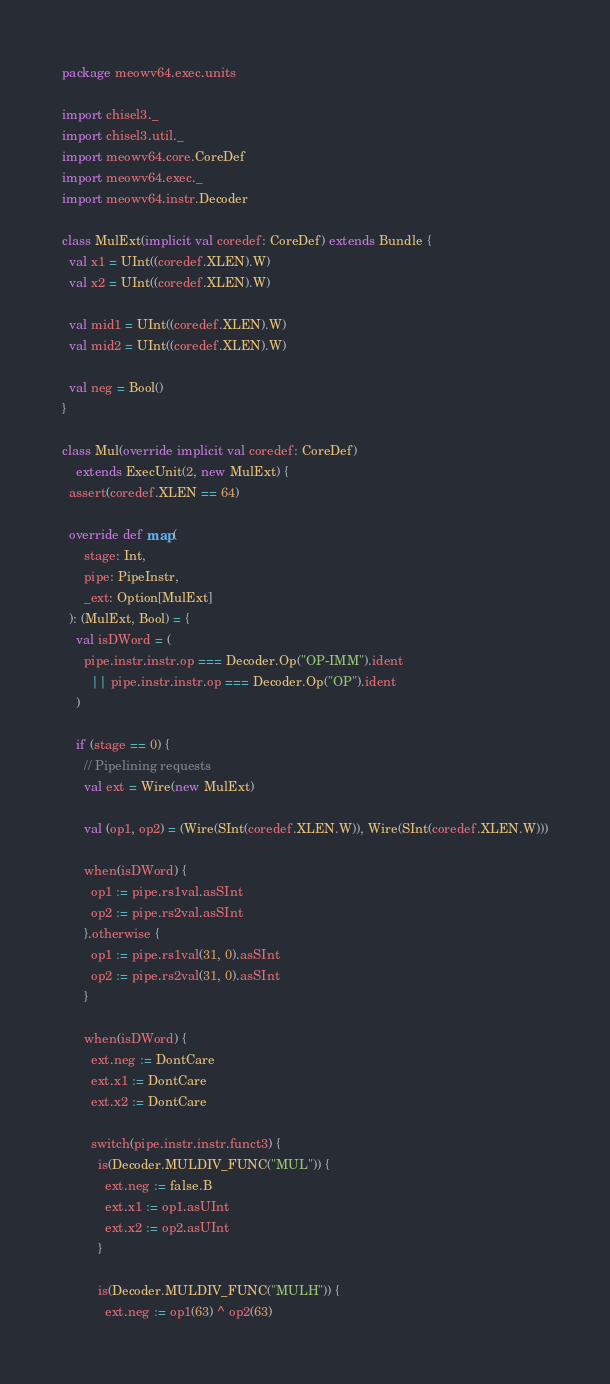Convert code to text. <code><loc_0><loc_0><loc_500><loc_500><_Scala_>package meowv64.exec.units

import chisel3._
import chisel3.util._
import meowv64.core.CoreDef
import meowv64.exec._
import meowv64.instr.Decoder

class MulExt(implicit val coredef: CoreDef) extends Bundle {
  val x1 = UInt((coredef.XLEN).W)
  val x2 = UInt((coredef.XLEN).W)

  val mid1 = UInt((coredef.XLEN).W)
  val mid2 = UInt((coredef.XLEN).W)

  val neg = Bool()
}

class Mul(override implicit val coredef: CoreDef)
    extends ExecUnit(2, new MulExt) {
  assert(coredef.XLEN == 64)

  override def map(
      stage: Int,
      pipe: PipeInstr,
      _ext: Option[MulExt]
  ): (MulExt, Bool) = {
    val isDWord = (
      pipe.instr.instr.op === Decoder.Op("OP-IMM").ident
        || pipe.instr.instr.op === Decoder.Op("OP").ident
    )

    if (stage == 0) {
      // Pipelining requests
      val ext = Wire(new MulExt)

      val (op1, op2) = (Wire(SInt(coredef.XLEN.W)), Wire(SInt(coredef.XLEN.W)))

      when(isDWord) {
        op1 := pipe.rs1val.asSInt
        op2 := pipe.rs2val.asSInt
      }.otherwise {
        op1 := pipe.rs1val(31, 0).asSInt
        op2 := pipe.rs2val(31, 0).asSInt
      }

      when(isDWord) {
        ext.neg := DontCare
        ext.x1 := DontCare
        ext.x2 := DontCare

        switch(pipe.instr.instr.funct3) {
          is(Decoder.MULDIV_FUNC("MUL")) {
            ext.neg := false.B
            ext.x1 := op1.asUInt
            ext.x2 := op2.asUInt
          }

          is(Decoder.MULDIV_FUNC("MULH")) {
            ext.neg := op1(63) ^ op2(63)</code> 